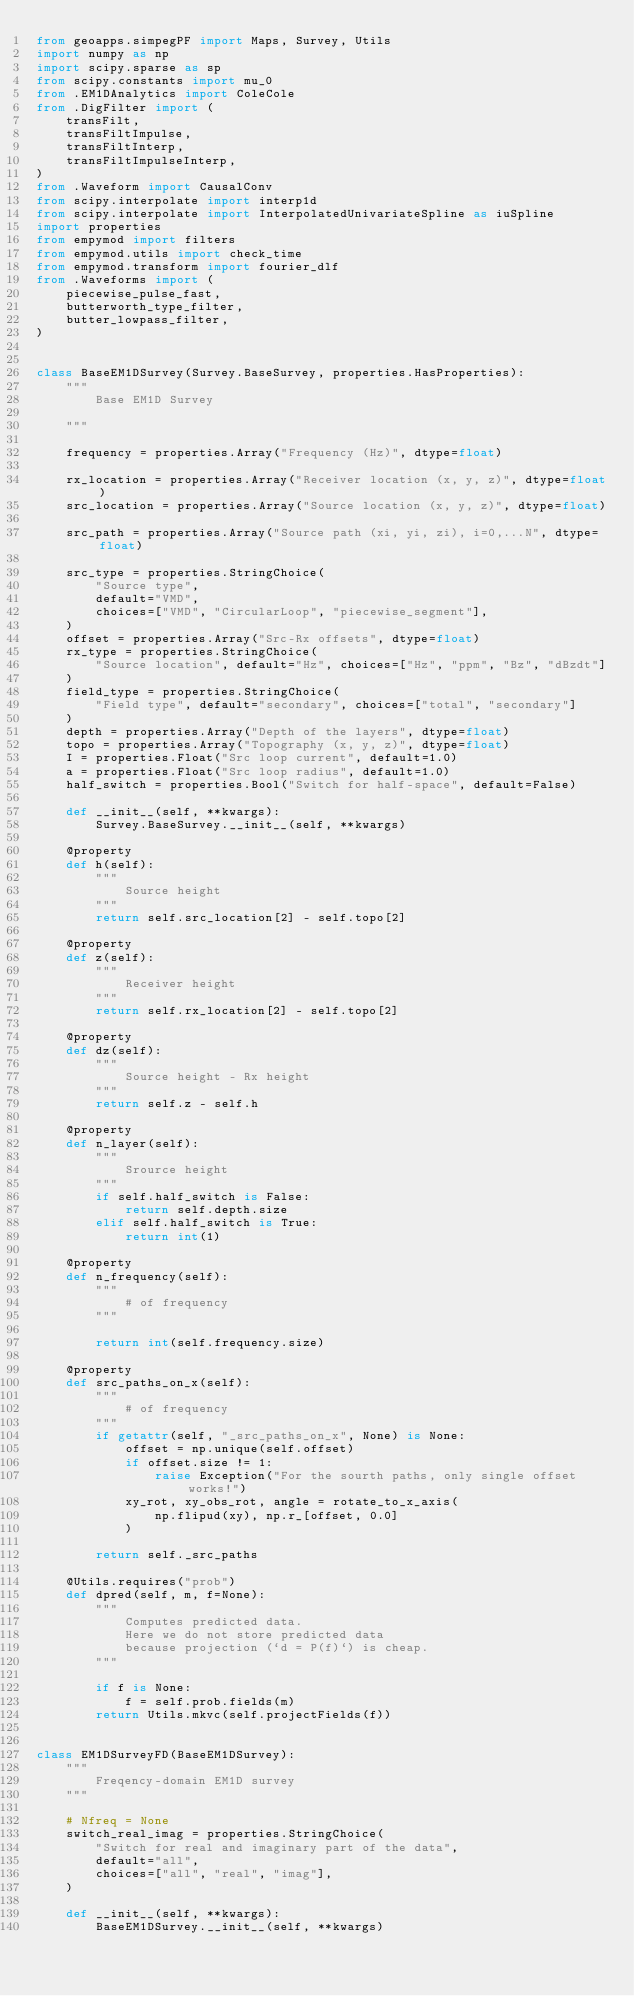Convert code to text. <code><loc_0><loc_0><loc_500><loc_500><_Python_>from geoapps.simpegPF import Maps, Survey, Utils
import numpy as np
import scipy.sparse as sp
from scipy.constants import mu_0
from .EM1DAnalytics import ColeCole
from .DigFilter import (
    transFilt,
    transFiltImpulse,
    transFiltInterp,
    transFiltImpulseInterp,
)
from .Waveform import CausalConv
from scipy.interpolate import interp1d
from scipy.interpolate import InterpolatedUnivariateSpline as iuSpline
import properties
from empymod import filters
from empymod.utils import check_time
from empymod.transform import fourier_dlf
from .Waveforms import (
    piecewise_pulse_fast,
    butterworth_type_filter,
    butter_lowpass_filter,
)


class BaseEM1DSurvey(Survey.BaseSurvey, properties.HasProperties):
    """
        Base EM1D Survey

    """

    frequency = properties.Array("Frequency (Hz)", dtype=float)

    rx_location = properties.Array("Receiver location (x, y, z)", dtype=float)
    src_location = properties.Array("Source location (x, y, z)", dtype=float)

    src_path = properties.Array("Source path (xi, yi, zi), i=0,...N", dtype=float)

    src_type = properties.StringChoice(
        "Source type",
        default="VMD",
        choices=["VMD", "CircularLoop", "piecewise_segment"],
    )
    offset = properties.Array("Src-Rx offsets", dtype=float)
    rx_type = properties.StringChoice(
        "Source location", default="Hz", choices=["Hz", "ppm", "Bz", "dBzdt"]
    )
    field_type = properties.StringChoice(
        "Field type", default="secondary", choices=["total", "secondary"]
    )
    depth = properties.Array("Depth of the layers", dtype=float)
    topo = properties.Array("Topography (x, y, z)", dtype=float)
    I = properties.Float("Src loop current", default=1.0)
    a = properties.Float("Src loop radius", default=1.0)
    half_switch = properties.Bool("Switch for half-space", default=False)

    def __init__(self, **kwargs):
        Survey.BaseSurvey.__init__(self, **kwargs)

    @property
    def h(self):
        """
            Source height
        """
        return self.src_location[2] - self.topo[2]

    @property
    def z(self):
        """
            Receiver height
        """
        return self.rx_location[2] - self.topo[2]

    @property
    def dz(self):
        """
            Source height - Rx height
        """
        return self.z - self.h

    @property
    def n_layer(self):
        """
            Srource height
        """
        if self.half_switch is False:
            return self.depth.size
        elif self.half_switch is True:
            return int(1)

    @property
    def n_frequency(self):
        """
            # of frequency
        """

        return int(self.frequency.size)

    @property
    def src_paths_on_x(self):
        """
            # of frequency
        """
        if getattr(self, "_src_paths_on_x", None) is None:
            offset = np.unique(self.offset)
            if offset.size != 1:
                raise Exception("For the sourth paths, only single offset works!")
            xy_rot, xy_obs_rot, angle = rotate_to_x_axis(
                np.flipud(xy), np.r_[offset, 0.0]
            )

        return self._src_paths

    @Utils.requires("prob")
    def dpred(self, m, f=None):
        """
            Computes predicted data.
            Here we do not store predicted data
            because projection (`d = P(f)`) is cheap.
        """

        if f is None:
            f = self.prob.fields(m)
        return Utils.mkvc(self.projectFields(f))


class EM1DSurveyFD(BaseEM1DSurvey):
    """
        Freqency-domain EM1D survey
    """

    # Nfreq = None
    switch_real_imag = properties.StringChoice(
        "Switch for real and imaginary part of the data",
        default="all",
        choices=["all", "real", "imag"],
    )

    def __init__(self, **kwargs):
        BaseEM1DSurvey.__init__(self, **kwargs)
</code> 